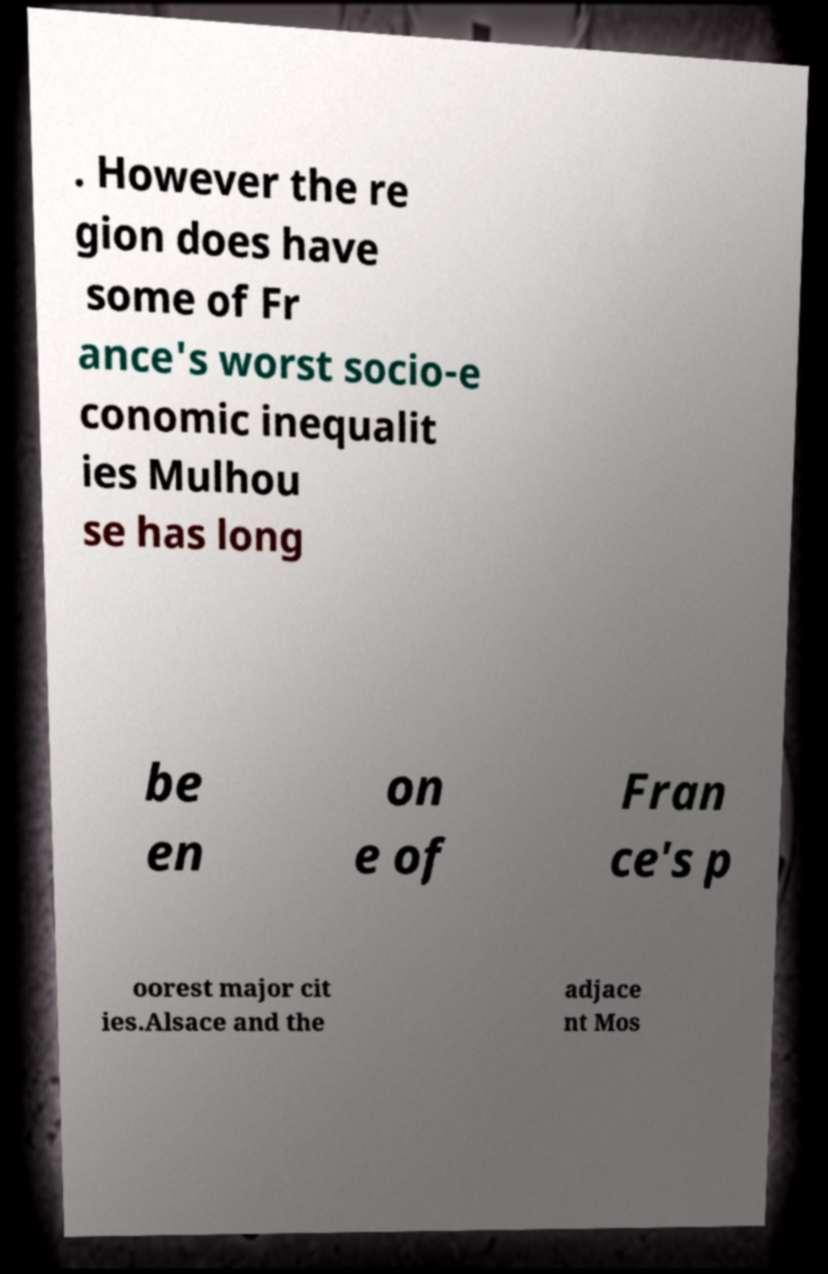Please identify and transcribe the text found in this image. . However the re gion does have some of Fr ance's worst socio-e conomic inequalit ies Mulhou se has long be en on e of Fran ce's p oorest major cit ies.Alsace and the adjace nt Mos 